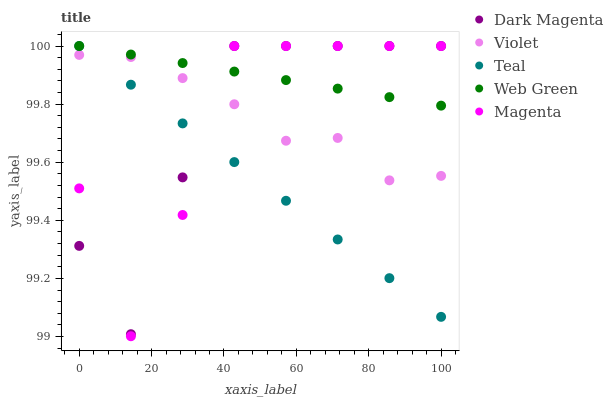Does Teal have the minimum area under the curve?
Answer yes or no. Yes. Does Web Green have the maximum area under the curve?
Answer yes or no. Yes. Does Dark Magenta have the minimum area under the curve?
Answer yes or no. No. Does Dark Magenta have the maximum area under the curve?
Answer yes or no. No. Is Web Green the smoothest?
Answer yes or no. Yes. Is Magenta the roughest?
Answer yes or no. Yes. Is Dark Magenta the smoothest?
Answer yes or no. No. Is Dark Magenta the roughest?
Answer yes or no. No. Does Magenta have the lowest value?
Answer yes or no. Yes. Does Dark Magenta have the lowest value?
Answer yes or no. No. Does Teal have the highest value?
Answer yes or no. Yes. Does Violet have the highest value?
Answer yes or no. No. Is Violet less than Web Green?
Answer yes or no. Yes. Is Web Green greater than Violet?
Answer yes or no. Yes. Does Magenta intersect Web Green?
Answer yes or no. Yes. Is Magenta less than Web Green?
Answer yes or no. No. Is Magenta greater than Web Green?
Answer yes or no. No. Does Violet intersect Web Green?
Answer yes or no. No. 